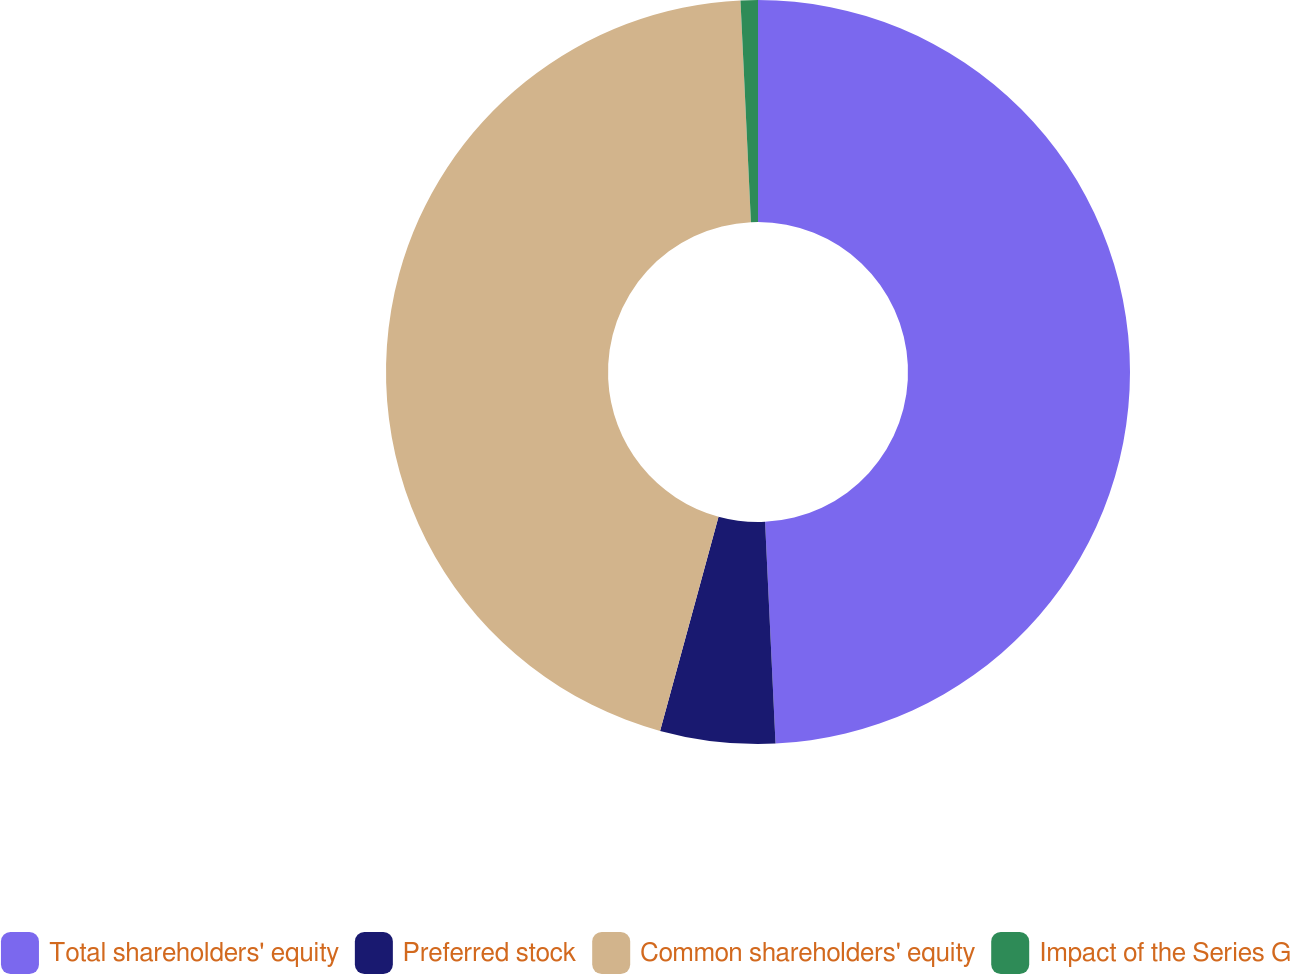Convert chart to OTSL. <chart><loc_0><loc_0><loc_500><loc_500><pie_chart><fcel>Total shareholders' equity<fcel>Preferred stock<fcel>Common shareholders' equity<fcel>Impact of the Series G<nl><fcel>49.25%<fcel>4.99%<fcel>45.01%<fcel>0.75%<nl></chart> 